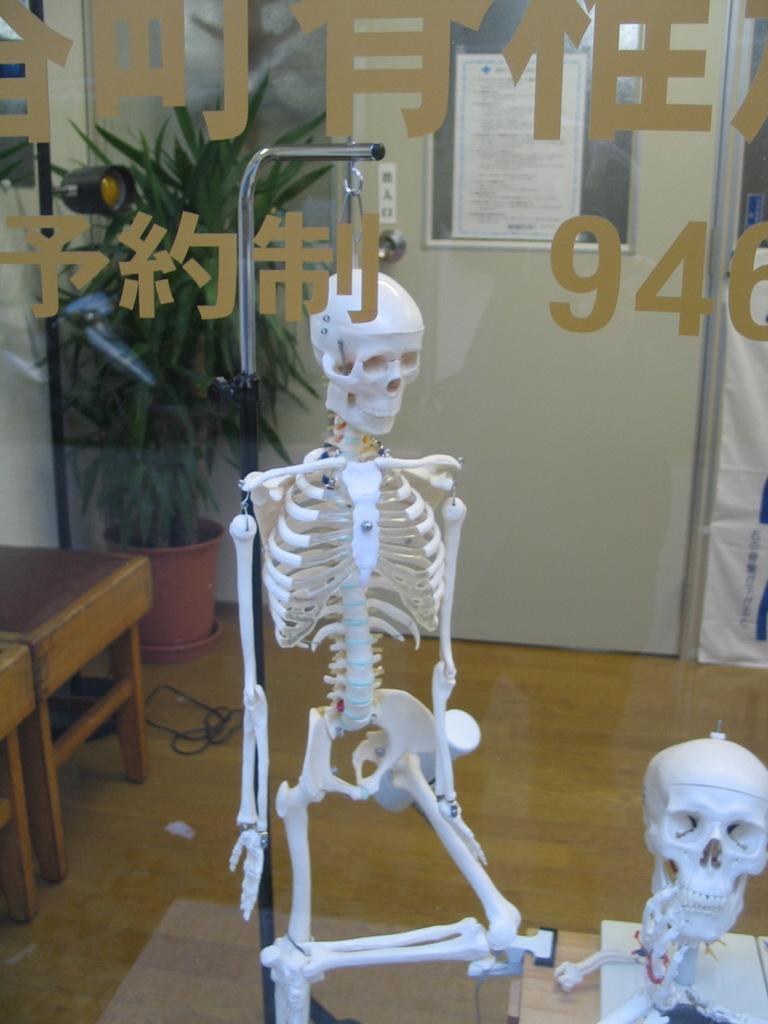Describe this image in one or two sentences. In this image, I can see a skeleton hanging to a stand. At the bottom right side of the image, there is a skull on an object. I can see a glass door with letters and numbers on it. In the background, I can see a plant in a flower pot and a poster attached to the door. On the right side of the image, It looks like a chair. 